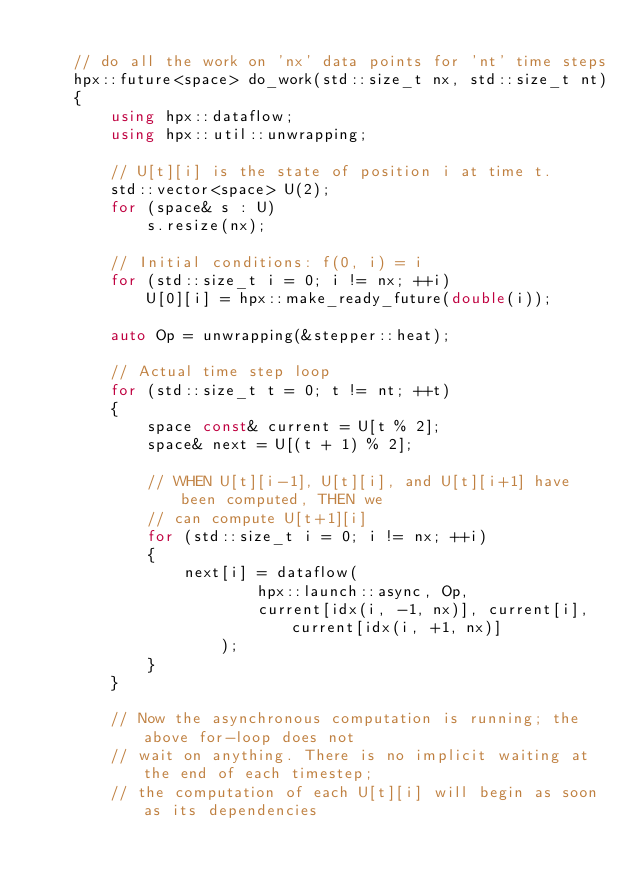Convert code to text. <code><loc_0><loc_0><loc_500><loc_500><_C++_>
    // do all the work on 'nx' data points for 'nt' time steps
    hpx::future<space> do_work(std::size_t nx, std::size_t nt)
    {
        using hpx::dataflow;
        using hpx::util::unwrapping;

        // U[t][i] is the state of position i at time t.
        std::vector<space> U(2);
        for (space& s : U)
            s.resize(nx);

        // Initial conditions: f(0, i) = i
        for (std::size_t i = 0; i != nx; ++i)
            U[0][i] = hpx::make_ready_future(double(i));

        auto Op = unwrapping(&stepper::heat);

        // Actual time step loop
        for (std::size_t t = 0; t != nt; ++t)
        {
            space const& current = U[t % 2];
            space& next = U[(t + 1) % 2];

            // WHEN U[t][i-1], U[t][i], and U[t][i+1] have been computed, THEN we
            // can compute U[t+1][i]
            for (std::size_t i = 0; i != nx; ++i)
            {
                next[i] = dataflow(
                        hpx::launch::async, Op,
                        current[idx(i, -1, nx)], current[i], current[idx(i, +1, nx)]
                    );
            }
        }

        // Now the asynchronous computation is running; the above for-loop does not
        // wait on anything. There is no implicit waiting at the end of each timestep;
        // the computation of each U[t][i] will begin as soon as its dependencies</code> 